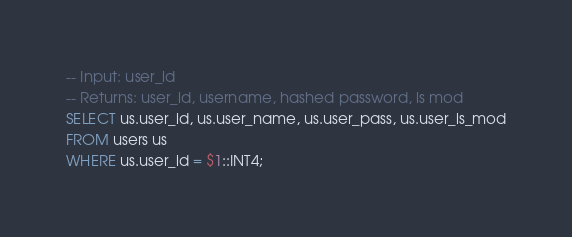Convert code to text. <code><loc_0><loc_0><loc_500><loc_500><_SQL_>-- Input: user_id
-- Returns: user_id, username, hashed password, is mod
SELECT us.user_id, us.user_name, us.user_pass, us.user_is_mod
FROM users us
WHERE us.user_id = $1::INT4;</code> 